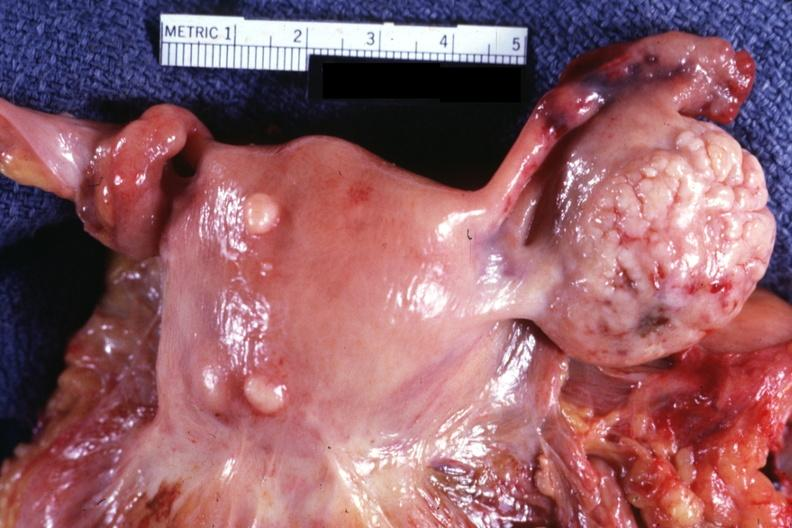s leiomyoma present?
Answer the question using a single word or phrase. Yes 